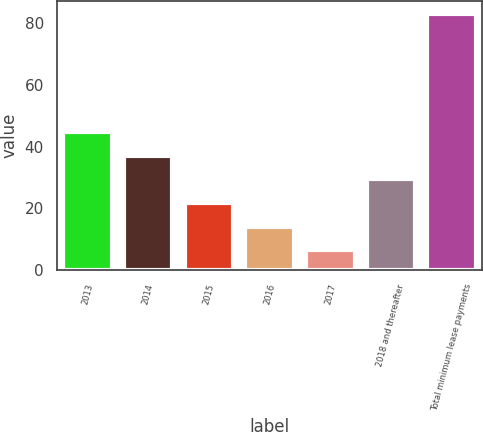Convert chart. <chart><loc_0><loc_0><loc_500><loc_500><bar_chart><fcel>2013<fcel>2014<fcel>2015<fcel>2016<fcel>2017<fcel>2018 and thereafter<fcel>Total minimum lease payments<nl><fcel>44.7<fcel>37.04<fcel>21.72<fcel>14.06<fcel>6.4<fcel>29.38<fcel>83<nl></chart> 